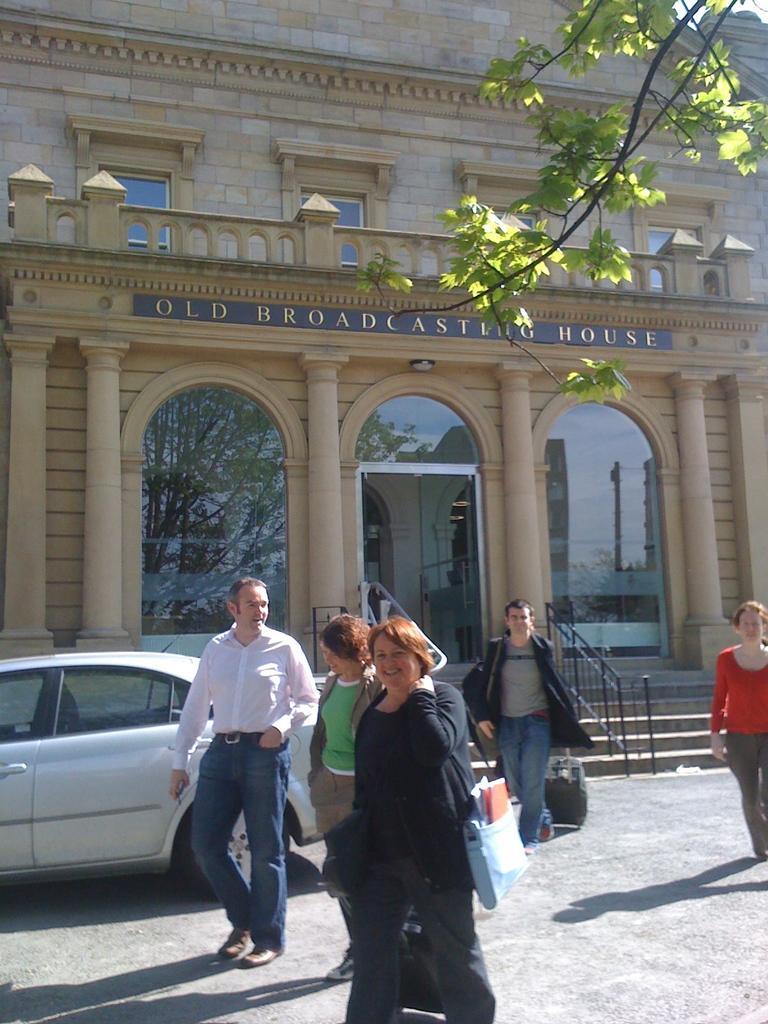Please provide a concise description of this image. In this image I can see the ground, few people standing, a car which is grey in color, few trees, few stairs, the railing and a building which is cream in color. 